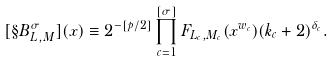<formula> <loc_0><loc_0><loc_500><loc_500>[ \S B ^ { \sigma } _ { L , M } ] ( x ) \equiv 2 ^ { - [ p / 2 ] } \prod _ { c = 1 } ^ { [ \sigma ] } F _ { L _ { c } , M _ { c } } ( x ^ { w _ { c } } ) ( k _ { c } + 2 ) ^ { \delta _ { c } } .</formula> 